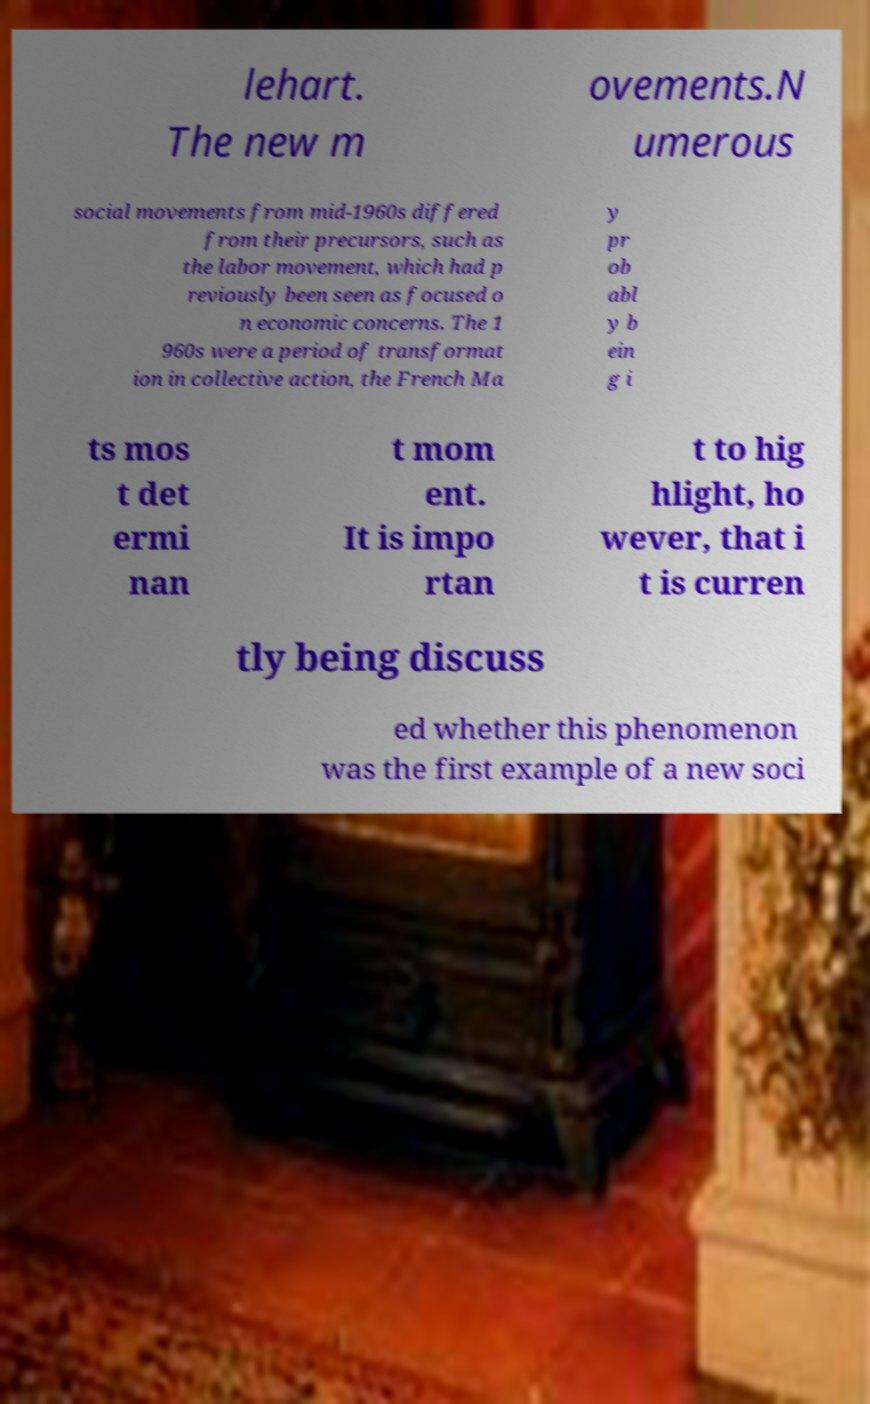For documentation purposes, I need the text within this image transcribed. Could you provide that? lehart. The new m ovements.N umerous social movements from mid-1960s differed from their precursors, such as the labor movement, which had p reviously been seen as focused o n economic concerns. The 1 960s were a period of transformat ion in collective action, the French Ma y pr ob abl y b ein g i ts mos t det ermi nan t mom ent. It is impo rtan t to hig hlight, ho wever, that i t is curren tly being discuss ed whether this phenomenon was the first example of a new soci 